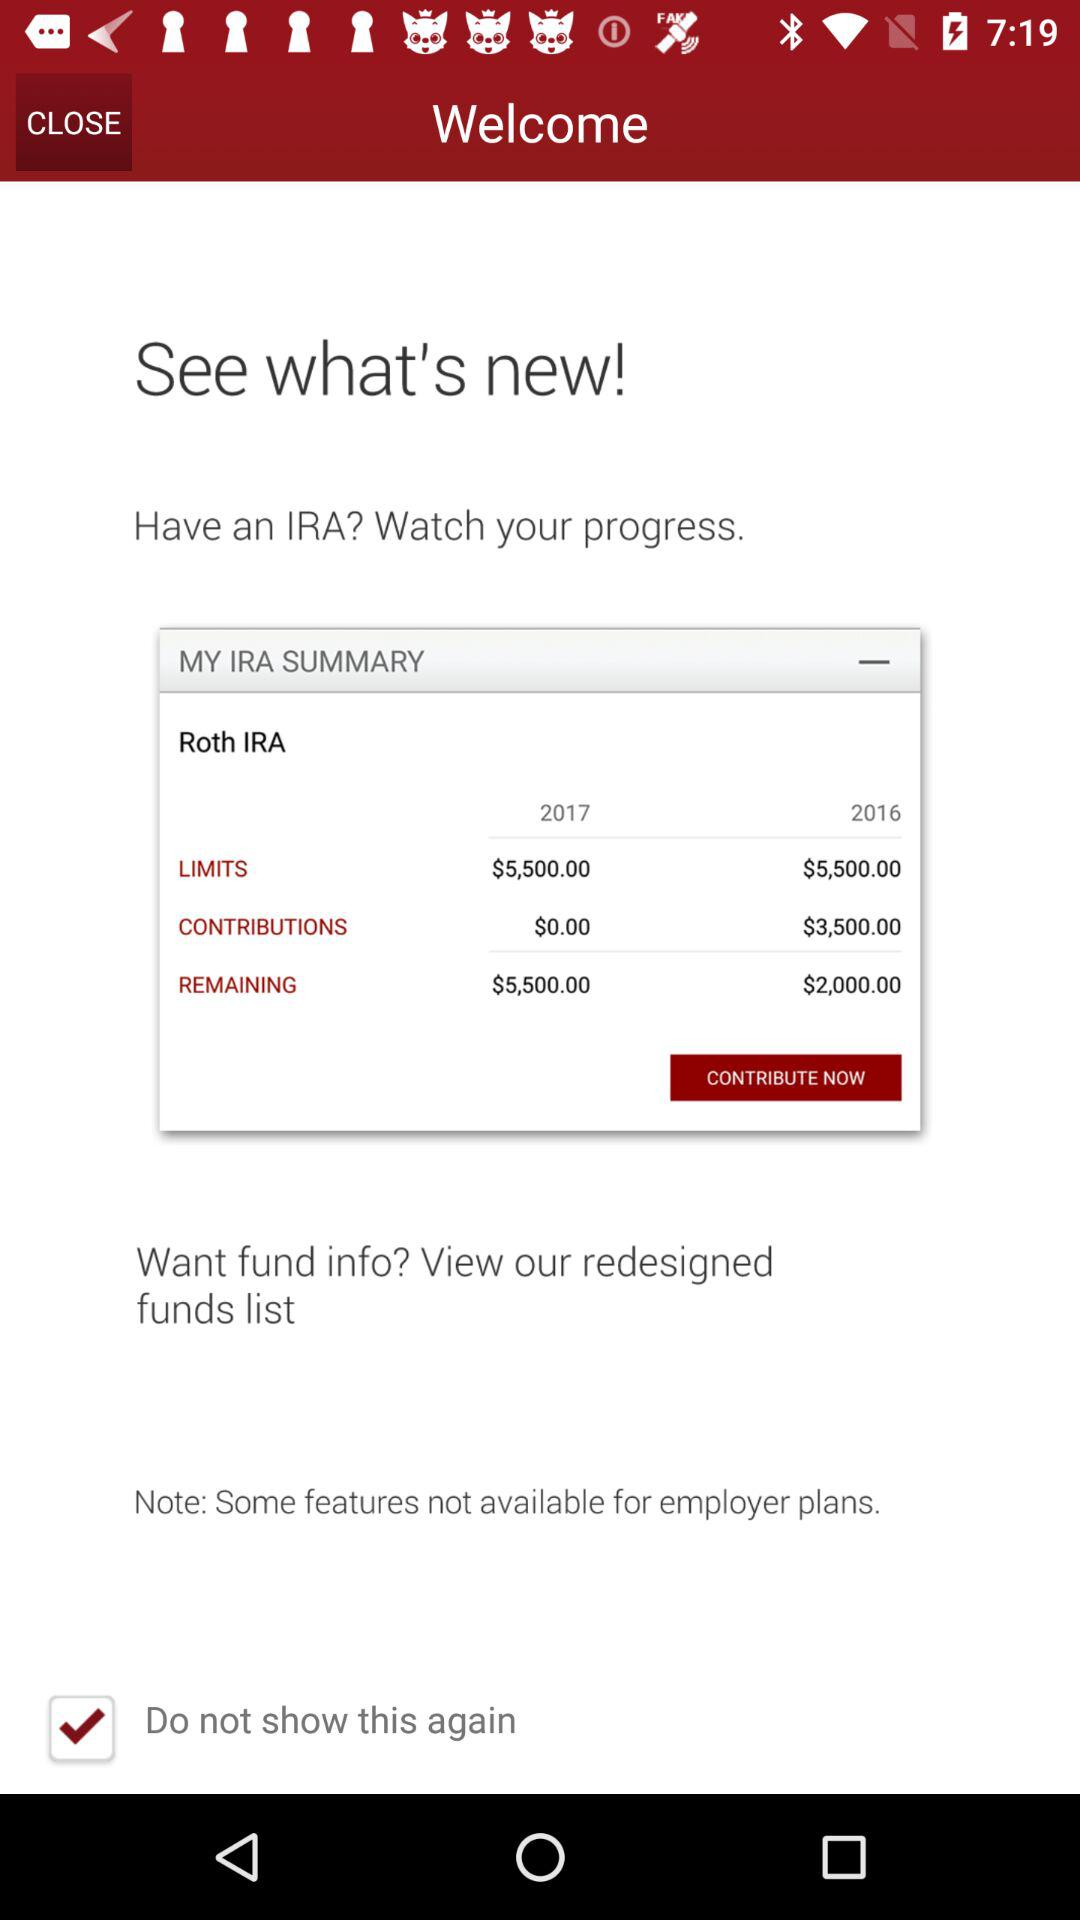What is the remaining amount for 2016? The remaining amount for 2016 is $2,000. 